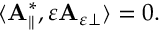Convert formula to latex. <formula><loc_0><loc_0><loc_500><loc_500>\begin{array} { r } { \langle A _ { \| } ^ { * } , \varepsilon A _ { \varepsilon \perp } \rangle = 0 . } \end{array}</formula> 